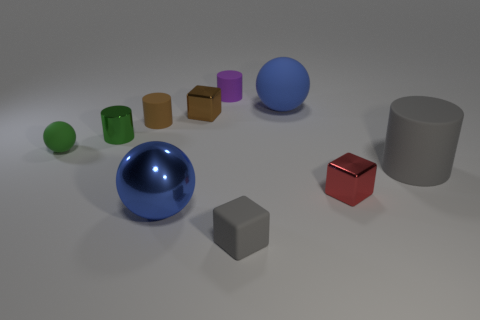Subtract all balls. How many objects are left? 7 Subtract 0 cyan blocks. How many objects are left? 10 Subtract all brown metal blocks. Subtract all small green balls. How many objects are left? 8 Add 4 small green spheres. How many small green spheres are left? 5 Add 4 tiny gray objects. How many tiny gray objects exist? 5 